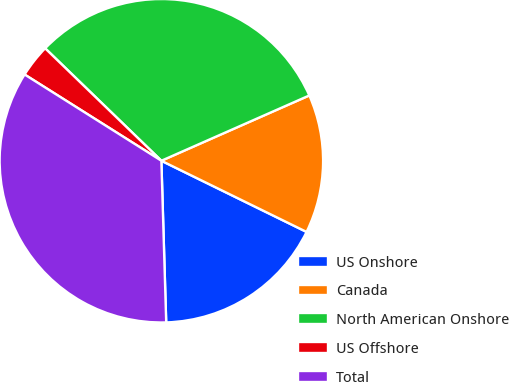Convert chart. <chart><loc_0><loc_0><loc_500><loc_500><pie_chart><fcel>US Onshore<fcel>Canada<fcel>North American Onshore<fcel>US Offshore<fcel>Total<nl><fcel>17.27%<fcel>13.87%<fcel>31.15%<fcel>3.28%<fcel>34.43%<nl></chart> 